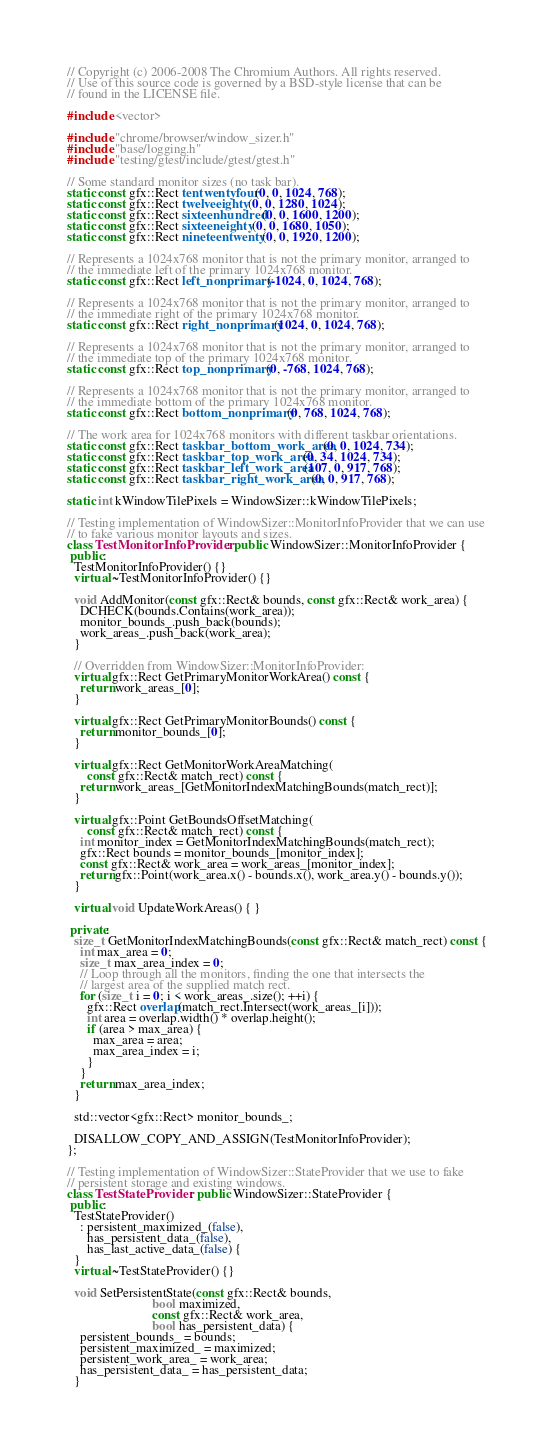Convert code to text. <code><loc_0><loc_0><loc_500><loc_500><_C++_>// Copyright (c) 2006-2008 The Chromium Authors. All rights reserved.
// Use of this source code is governed by a BSD-style license that can be
// found in the LICENSE file.

#include <vector>

#include "chrome/browser/window_sizer.h"
#include "base/logging.h"
#include "testing/gtest/include/gtest/gtest.h"

// Some standard monitor sizes (no task bar).
static const gfx::Rect tentwentyfour(0, 0, 1024, 768);
static const gfx::Rect twelveeighty(0, 0, 1280, 1024);
static const gfx::Rect sixteenhundred(0, 0, 1600, 1200);
static const gfx::Rect sixteeneighty(0, 0, 1680, 1050);
static const gfx::Rect nineteentwenty(0, 0, 1920, 1200);

// Represents a 1024x768 monitor that is not the primary monitor, arranged to
// the immediate left of the primary 1024x768 monitor.
static const gfx::Rect left_nonprimary(-1024, 0, 1024, 768);

// Represents a 1024x768 monitor that is not the primary monitor, arranged to
// the immediate right of the primary 1024x768 monitor.
static const gfx::Rect right_nonprimary(1024, 0, 1024, 768);

// Represents a 1024x768 monitor that is not the primary monitor, arranged to
// the immediate top of the primary 1024x768 monitor.
static const gfx::Rect top_nonprimary(0, -768, 1024, 768);

// Represents a 1024x768 monitor that is not the primary monitor, arranged to
// the immediate bottom of the primary 1024x768 monitor.
static const gfx::Rect bottom_nonprimary(0, 768, 1024, 768);

// The work area for 1024x768 monitors with different taskbar orientations.
static const gfx::Rect taskbar_bottom_work_area(0, 0, 1024, 734);
static const gfx::Rect taskbar_top_work_area(0, 34, 1024, 734);
static const gfx::Rect taskbar_left_work_area(107, 0, 917, 768);
static const gfx::Rect taskbar_right_work_area(0, 0, 917, 768);

static int kWindowTilePixels = WindowSizer::kWindowTilePixels;

// Testing implementation of WindowSizer::MonitorInfoProvider that we can use
// to fake various monitor layouts and sizes.
class TestMonitorInfoProvider : public WindowSizer::MonitorInfoProvider {
 public:
  TestMonitorInfoProvider() {}
  virtual ~TestMonitorInfoProvider() {}

  void AddMonitor(const gfx::Rect& bounds, const gfx::Rect& work_area) {
    DCHECK(bounds.Contains(work_area));
    monitor_bounds_.push_back(bounds);
    work_areas_.push_back(work_area);
  }

  // Overridden from WindowSizer::MonitorInfoProvider:
  virtual gfx::Rect GetPrimaryMonitorWorkArea() const {
    return work_areas_[0];
  }

  virtual gfx::Rect GetPrimaryMonitorBounds() const {
    return monitor_bounds_[0];
  }

  virtual gfx::Rect GetMonitorWorkAreaMatching(
      const gfx::Rect& match_rect) const {
    return work_areas_[GetMonitorIndexMatchingBounds(match_rect)];
  }

  virtual gfx::Point GetBoundsOffsetMatching(
      const gfx::Rect& match_rect) const {
    int monitor_index = GetMonitorIndexMatchingBounds(match_rect);
    gfx::Rect bounds = monitor_bounds_[monitor_index];
    const gfx::Rect& work_area = work_areas_[monitor_index];
    return gfx::Point(work_area.x() - bounds.x(), work_area.y() - bounds.y());
  }

  virtual void UpdateWorkAreas() { }

 private:
  size_t GetMonitorIndexMatchingBounds(const gfx::Rect& match_rect) const {
    int max_area = 0;
    size_t max_area_index = 0;
    // Loop through all the monitors, finding the one that intersects the
    // largest area of the supplied match rect.
    for (size_t i = 0; i < work_areas_.size(); ++i) {
      gfx::Rect overlap(match_rect.Intersect(work_areas_[i]));
      int area = overlap.width() * overlap.height();
      if (area > max_area) {
        max_area = area;
        max_area_index = i;
      }
    }
    return max_area_index;
  }

  std::vector<gfx::Rect> monitor_bounds_;

  DISALLOW_COPY_AND_ASSIGN(TestMonitorInfoProvider);
};

// Testing implementation of WindowSizer::StateProvider that we use to fake
// persistent storage and existing windows.
class TestStateProvider : public WindowSizer::StateProvider {
 public:
  TestStateProvider()
    : persistent_maximized_(false),
      has_persistent_data_(false),
      has_last_active_data_(false) {
  }
  virtual ~TestStateProvider() {}

  void SetPersistentState(const gfx::Rect& bounds,
                          bool maximized,
                          const gfx::Rect& work_area,
                          bool has_persistent_data) {
    persistent_bounds_ = bounds;
    persistent_maximized_ = maximized;
    persistent_work_area_ = work_area;
    has_persistent_data_ = has_persistent_data;
  }
</code> 